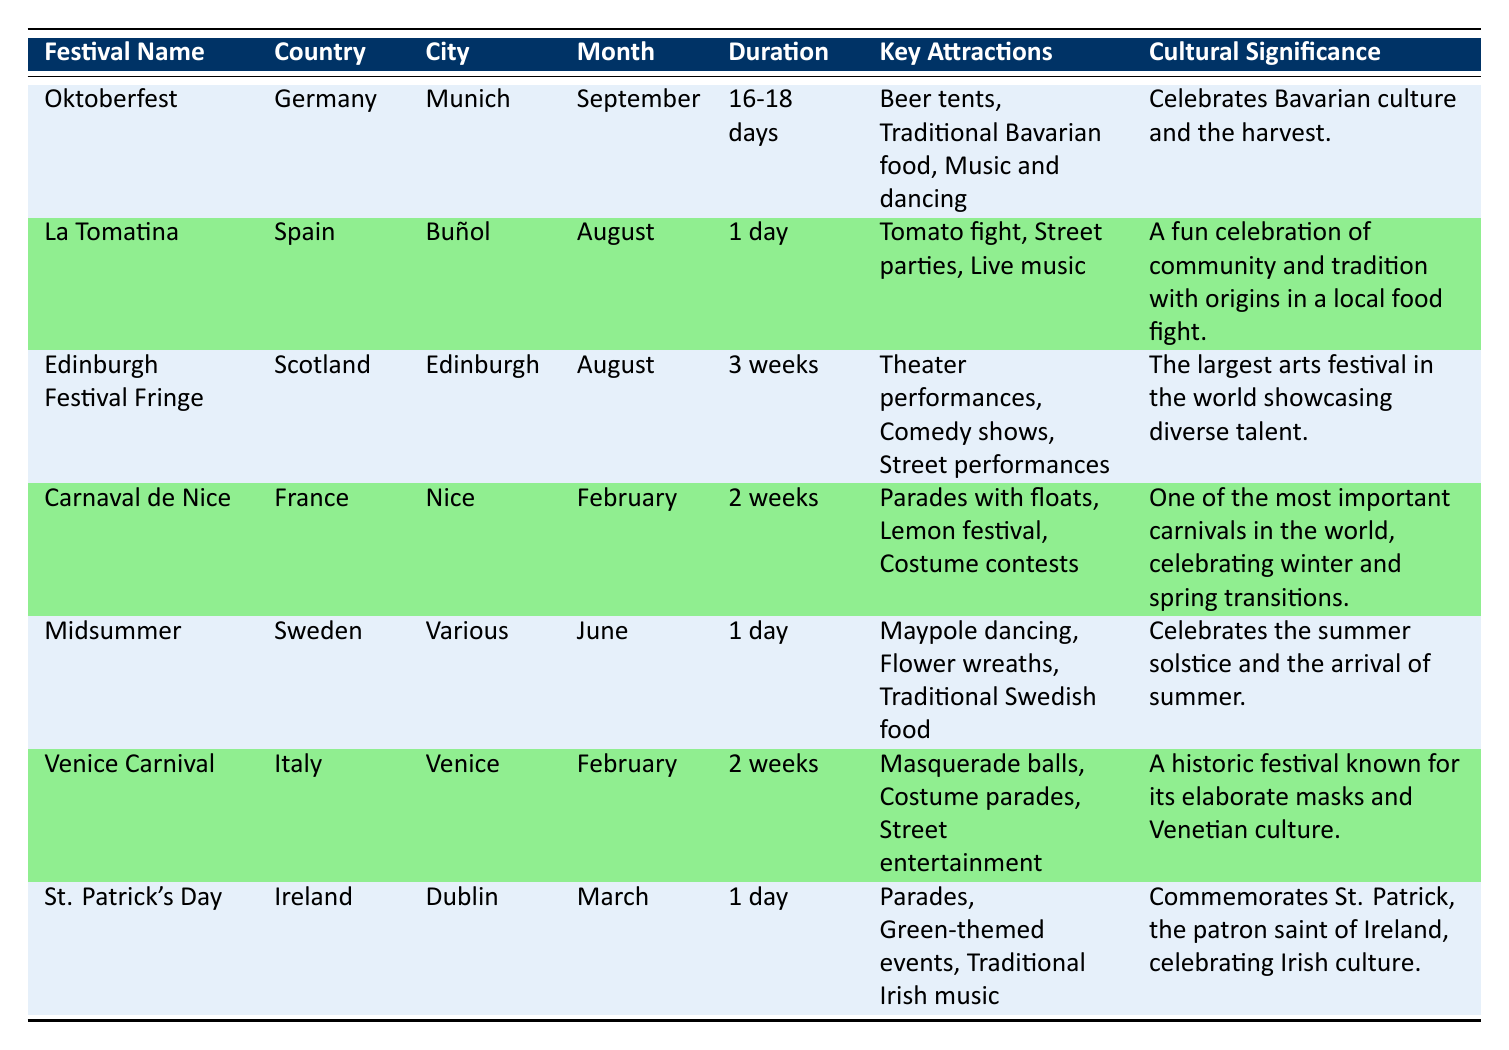What is the duration of Oktoberfest? The table indicates that Oktoberfest lasts for "16-18 days." Therefore, the answer is straightforwardly obtained from the corresponding row under the "Duration" column.
Answer: 16-18 days Which country hosts the Midsummer festival? Referring to the table, the Midsummer festival is hosted in Sweden, as stated in the "Country" column for that festival.
Answer: Sweden How many festivals take place in August? The table lists two festivals occurring in August: La Tomatina and the Edinburgh Festival Fringe. Counting these entries gives a total of 2 festivals in August.
Answer: 2 Is the Venice Carnival longer than the Carnaval de Nice? The duration of the Venice Carnival is 2 weeks, while Carnaval de Nice also lasts for 2 weeks. Therefore, they are equal in duration. The answer is "No."
Answer: No What is the average duration of the festivals that last more than 1 day? To find the average, we first identify the festivals longer than 1 day: Oktoberfest (16-18 days), Carnaval de Nice (2 weeks), Venice Carnival (2 weeks), and Edinburgh Festival Fringe (3 weeks). The durations in days (approximated for calculation) are 17, 14, 14, and 21 respectively. The total is 66 days for 4 festivals (66/4 = 16.5).
Answer: 16.5 days Which festival is celebrated in Dublin? The data indicates that St. Patrick's Day is celebrated in Dublin, as listed in the "City" column.
Answer: St. Patrick's Day Are traditional Bavarian food and music and dancing key attractions of Oktoberfest? Yes, the table explicitly lists both traditional Bavarian food and music and dancing under the "Key Attractions" column for Oktoberfest.
Answer: Yes What is the cultural significance of the Edinburgh Festival Fringe? According to the table, the Edinburgh Festival Fringe is noted for being "The largest arts festival in the world showcasing diverse talent."
Answer: It celebrates diverse talent in the arts 